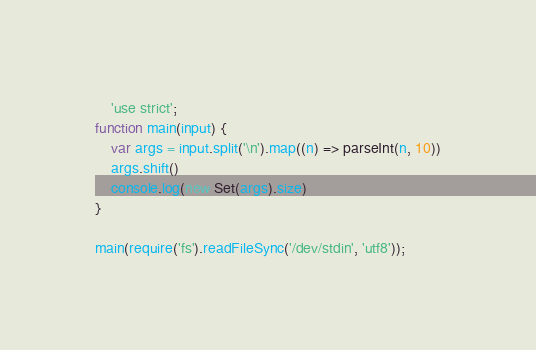Convert code to text. <code><loc_0><loc_0><loc_500><loc_500><_JavaScript_>	'use strict';
function main(input) {
    var args = input.split('\n').map((n) => parseInt(n, 10))
    args.shift()
  	console.log(new Set(args).size)
}
 
main(require('fs').readFileSync('/dev/stdin', 'utf8'));</code> 